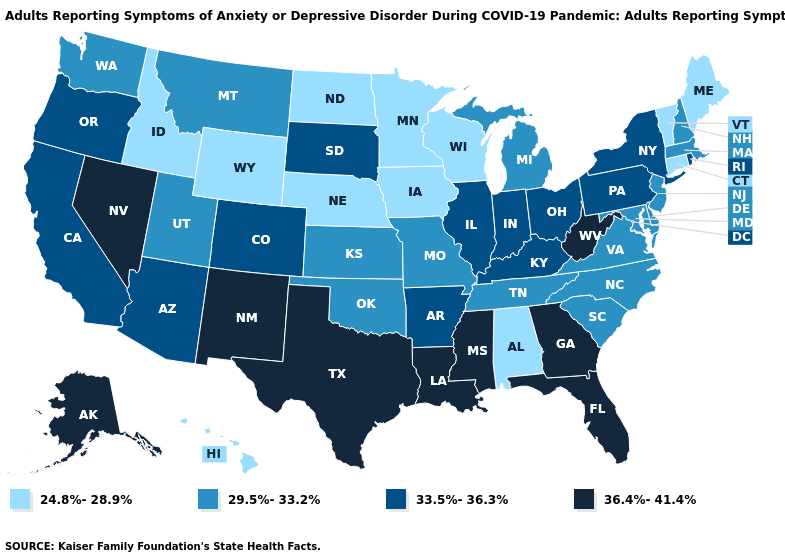Does Rhode Island have the lowest value in the Northeast?
Be succinct. No. Does Louisiana have the highest value in the USA?
Quick response, please. Yes. Which states hav the highest value in the Northeast?
Concise answer only. New York, Pennsylvania, Rhode Island. What is the value of Colorado?
Answer briefly. 33.5%-36.3%. What is the value of Kentucky?
Give a very brief answer. 33.5%-36.3%. Does the map have missing data?
Quick response, please. No. Among the states that border South Dakota , which have the lowest value?
Be succinct. Iowa, Minnesota, Nebraska, North Dakota, Wyoming. Name the states that have a value in the range 33.5%-36.3%?
Answer briefly. Arizona, Arkansas, California, Colorado, Illinois, Indiana, Kentucky, New York, Ohio, Oregon, Pennsylvania, Rhode Island, South Dakota. Which states have the highest value in the USA?
Keep it brief. Alaska, Florida, Georgia, Louisiana, Mississippi, Nevada, New Mexico, Texas, West Virginia. Among the states that border New Hampshire , does Vermont have the highest value?
Quick response, please. No. What is the lowest value in states that border California?
Concise answer only. 33.5%-36.3%. Does Georgia have the lowest value in the USA?
Give a very brief answer. No. Among the states that border New York , does Massachusetts have the highest value?
Be succinct. No. What is the value of Texas?
Quick response, please. 36.4%-41.4%. 